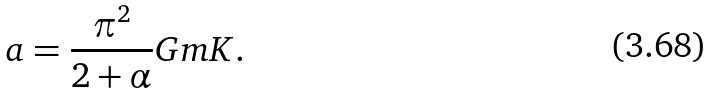<formula> <loc_0><loc_0><loc_500><loc_500>a = \frac { \pi ^ { 2 } } { 2 + \alpha } G m K .</formula> 